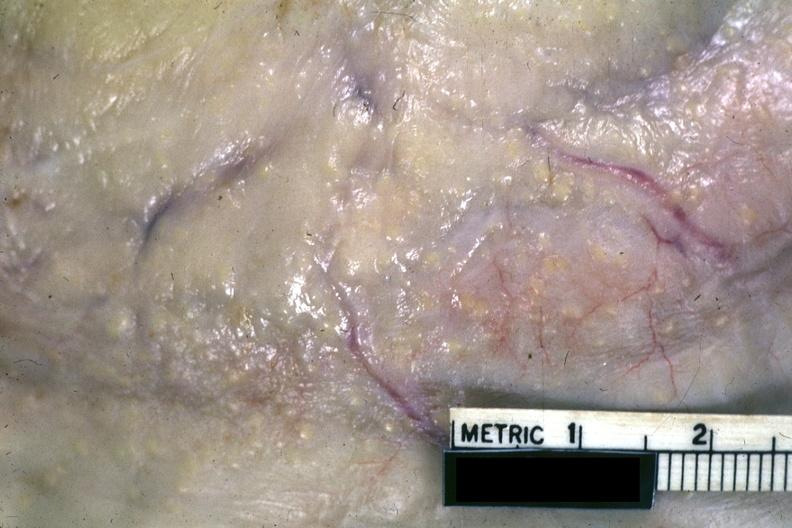s opened abdominal cavity with massive tumor in omentum none apparent in liver nor over peritoneal surfaces gut present?
Answer the question using a single word or phrase. No 